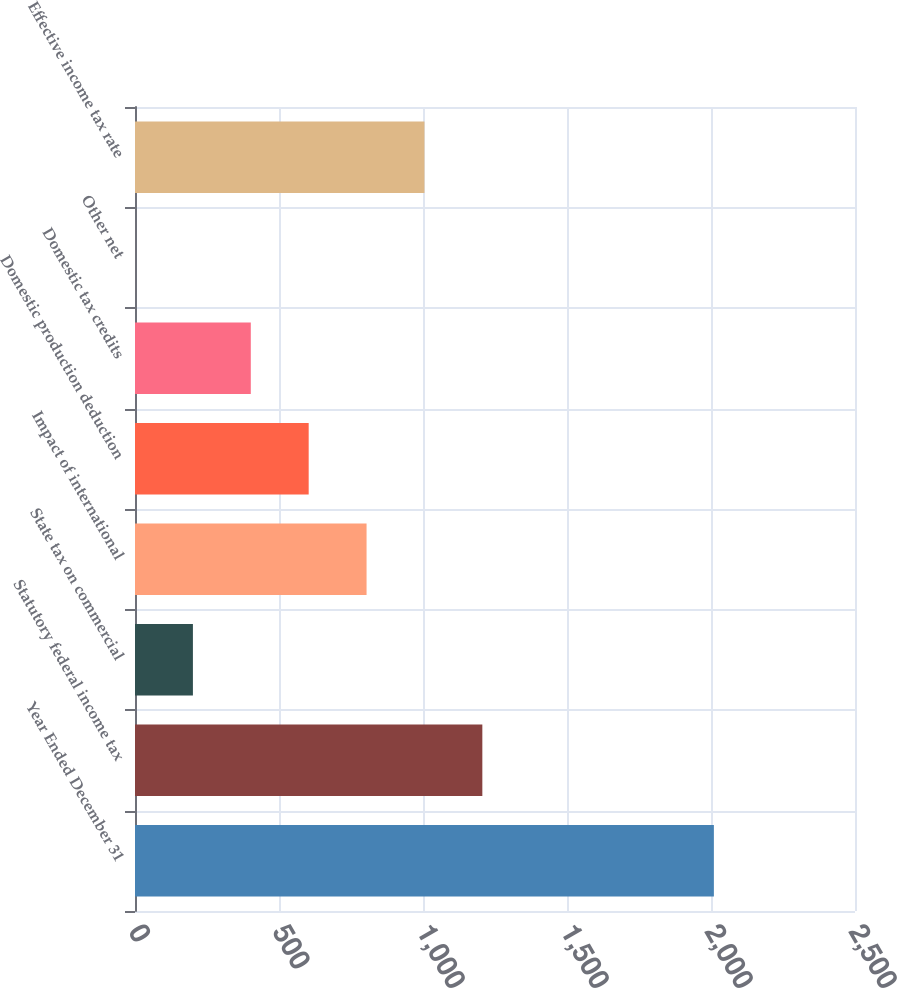<chart> <loc_0><loc_0><loc_500><loc_500><bar_chart><fcel>Year Ended December 31<fcel>Statutory federal income tax<fcel>State tax on commercial<fcel>Impact of international<fcel>Domestic production deduction<fcel>Domestic tax credits<fcel>Other net<fcel>Effective income tax rate<nl><fcel>2010<fcel>1206.04<fcel>201.09<fcel>804.06<fcel>603.07<fcel>402.08<fcel>0.1<fcel>1005.05<nl></chart> 